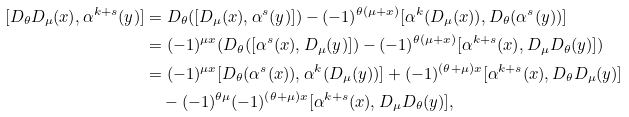Convert formula to latex. <formula><loc_0><loc_0><loc_500><loc_500>[ D _ { \theta } D _ { \mu } ( x ) , \alpha ^ { k + s } ( y ) ] & = D _ { \theta } ( [ D _ { \mu } ( x ) , \alpha ^ { s } ( y ) ] ) - ( - 1 ) ^ { \theta ( \mu + x ) } [ \alpha ^ { k } ( D _ { \mu } ( x ) ) , D _ { \theta } ( \alpha ^ { s } ( y ) ) ] \\ & = ( - 1 ) ^ { \mu x } ( D _ { \theta } ( [ \alpha ^ { s } ( x ) , D _ { \mu } ( y ) ] ) - ( - 1 ) ^ { \theta ( \mu + x ) } [ \alpha ^ { k + s } ( x ) , D _ { \mu } D _ { \theta } ( y ) ] ) \\ & = ( - 1 ) ^ { \mu x } [ D _ { \theta } ( \alpha ^ { s } ( x ) ) , \alpha ^ { k } ( D _ { \mu } ( y ) ) ] + ( - 1 ) ^ { ( \theta + \mu ) x } [ \alpha ^ { k + s } ( x ) , D _ { \theta } D _ { \mu } ( y ) ] \\ & \quad - ( - 1 ) ^ { \theta \mu } ( - 1 ) ^ { ( \theta + \mu ) x } [ \alpha ^ { k + s } ( x ) , D _ { \mu } D _ { \theta } ( y ) ] ,</formula> 